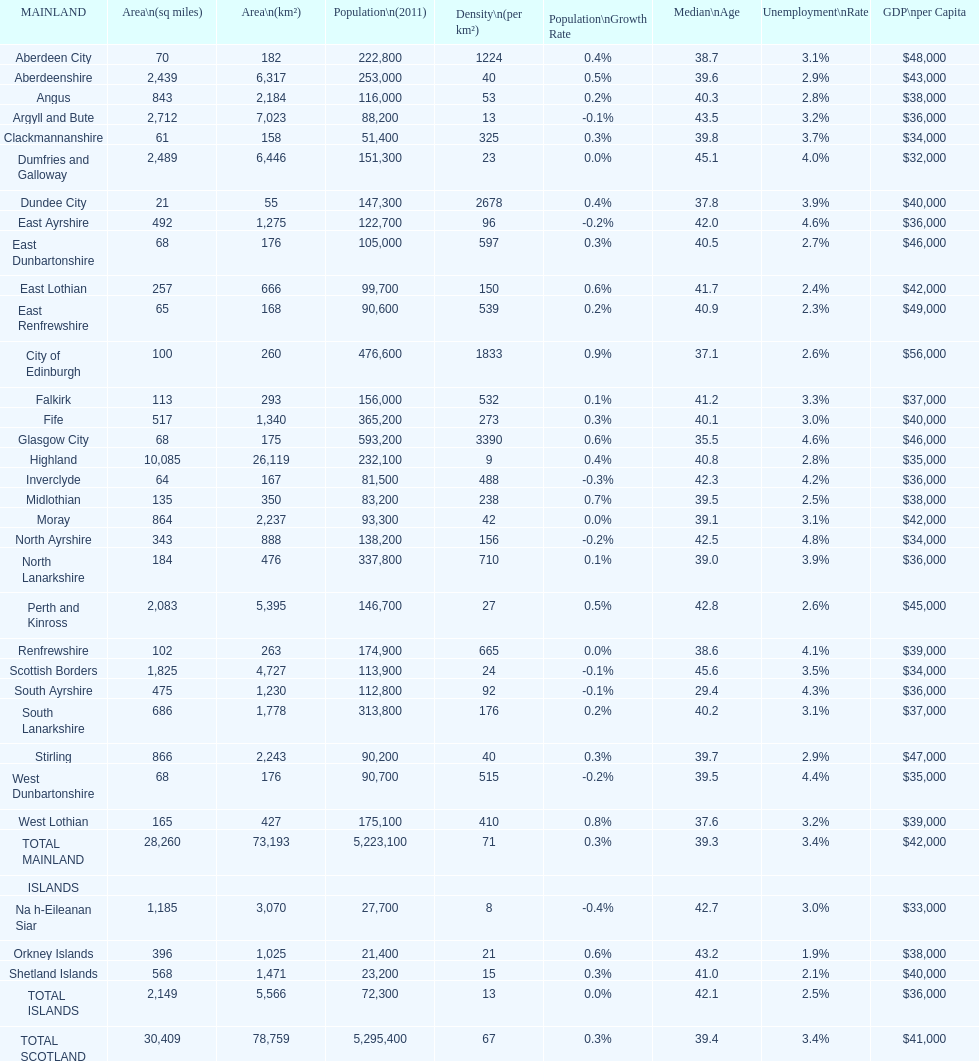What is the average population density in mainland cities? 71. Parse the full table. {'header': ['MAINLAND', 'Area\\n(sq miles)', 'Area\\n(km²)', 'Population\\n(2011)', 'Density\\n(per km²)', 'Population\\nGrowth Rate', 'Median\\nAge', 'Unemployment\\nRate', 'GDP\\nper Capita'], 'rows': [['Aberdeen City', '70', '182', '222,800', '1224', '0.4%', '38.7', '3.1%', '$48,000'], ['Aberdeenshire', '2,439', '6,317', '253,000', '40', '0.5%', '39.6', '2.9%', '$43,000'], ['Angus', '843', '2,184', '116,000', '53', '0.2%', '40.3', '2.8%', '$38,000'], ['Argyll and Bute', '2,712', '7,023', '88,200', '13', '-0.1%', '43.5', '3.2%', '$36,000'], ['Clackmannanshire', '61', '158', '51,400', '325', '0.3%', '39.8', '3.7%', '$34,000'], ['Dumfries and Galloway', '2,489', '6,446', '151,300', '23', '0.0%', '45.1', '4.0%', '$32,000'], ['Dundee City', '21', '55', '147,300', '2678', '0.4%', '37.8', '3.9%', '$40,000'], ['East Ayrshire', '492', '1,275', '122,700', '96', '-0.2%', '42.0', '4.6%', '$36,000'], ['East Dunbartonshire', '68', '176', '105,000', '597', '0.3%', '40.5', '2.7%', '$46,000'], ['East Lothian', '257', '666', '99,700', '150', '0.6%', '41.7', '2.4%', '$42,000'], ['East Renfrewshire', '65', '168', '90,600', '539', '0.2%', '40.9', '2.3%', '$49,000'], ['City of Edinburgh', '100', '260', '476,600', '1833', '0.9%', '37.1', '2.6%', '$56,000'], ['Falkirk', '113', '293', '156,000', '532', '0.1%', '41.2', '3.3%', '$37,000'], ['Fife', '517', '1,340', '365,200', '273', '0.3%', '40.1', '3.0%', '$40,000'], ['Glasgow City', '68', '175', '593,200', '3390', '0.6%', '35.5', '4.6%', '$46,000'], ['Highland', '10,085', '26,119', '232,100', '9', '0.4%', '40.8', '2.8%', '$35,000'], ['Inverclyde', '64', '167', '81,500', '488', '-0.3%', '42.3', '4.2%', '$36,000'], ['Midlothian', '135', '350', '83,200', '238', '0.7%', '39.5', '2.5%', '$38,000'], ['Moray', '864', '2,237', '93,300', '42', '0.0%', '39.1', '3.1%', '$42,000'], ['North Ayrshire', '343', '888', '138,200', '156', '-0.2%', '42.5', '4.8%', '$34,000'], ['North Lanarkshire', '184', '476', '337,800', '710', '0.1%', '39.0', '3.9%', '$36,000'], ['Perth and Kinross', '2,083', '5,395', '146,700', '27', '0.5%', '42.8', '2.6%', '$45,000'], ['Renfrewshire', '102', '263', '174,900', '665', '0.0%', '38.6', '4.1%', '$39,000'], ['Scottish Borders', '1,825', '4,727', '113,900', '24', '-0.1%', '45.6', '3.5%', '$34,000'], ['South Ayrshire', '475', '1,230', '112,800', '92', '-0.1%', '29.4', '4.3%', '$36,000'], ['South Lanarkshire', '686', '1,778', '313,800', '176', '0.2%', '40.2', '3.1%', '$37,000'], ['Stirling', '866', '2,243', '90,200', '40', '0.3%', '39.7', '2.9%', '$47,000'], ['West Dunbartonshire', '68', '176', '90,700', '515', '-0.2%', '39.5', '4.4%', '$35,000'], ['West Lothian', '165', '427', '175,100', '410', '0.8%', '37.6', '3.2%', '$39,000'], ['TOTAL MAINLAND', '28,260', '73,193', '5,223,100', '71', '0.3%', '39.3', '3.4%', '$42,000'], ['ISLANDS', '', '', '', '', '', '', '', ''], ['Na h-Eileanan Siar', '1,185', '3,070', '27,700', '8', '-0.4%', '42.7', '3.0%', '$33,000'], ['Orkney Islands', '396', '1,025', '21,400', '21', '0.6%', '43.2', '1.9%', '$38,000'], ['Shetland Islands', '568', '1,471', '23,200', '15', '0.3%', '41.0', '2.1%', '$40,000'], ['TOTAL ISLANDS', '2,149', '5,566', '72,300', '13', '0.0%', '42.1', '2.5%', '$36,000'], ['TOTAL SCOTLAND', '30,409', '78,759', '5,295,400', '67', '0.3%', '39.4', '3.4%', '$41,000']]} 